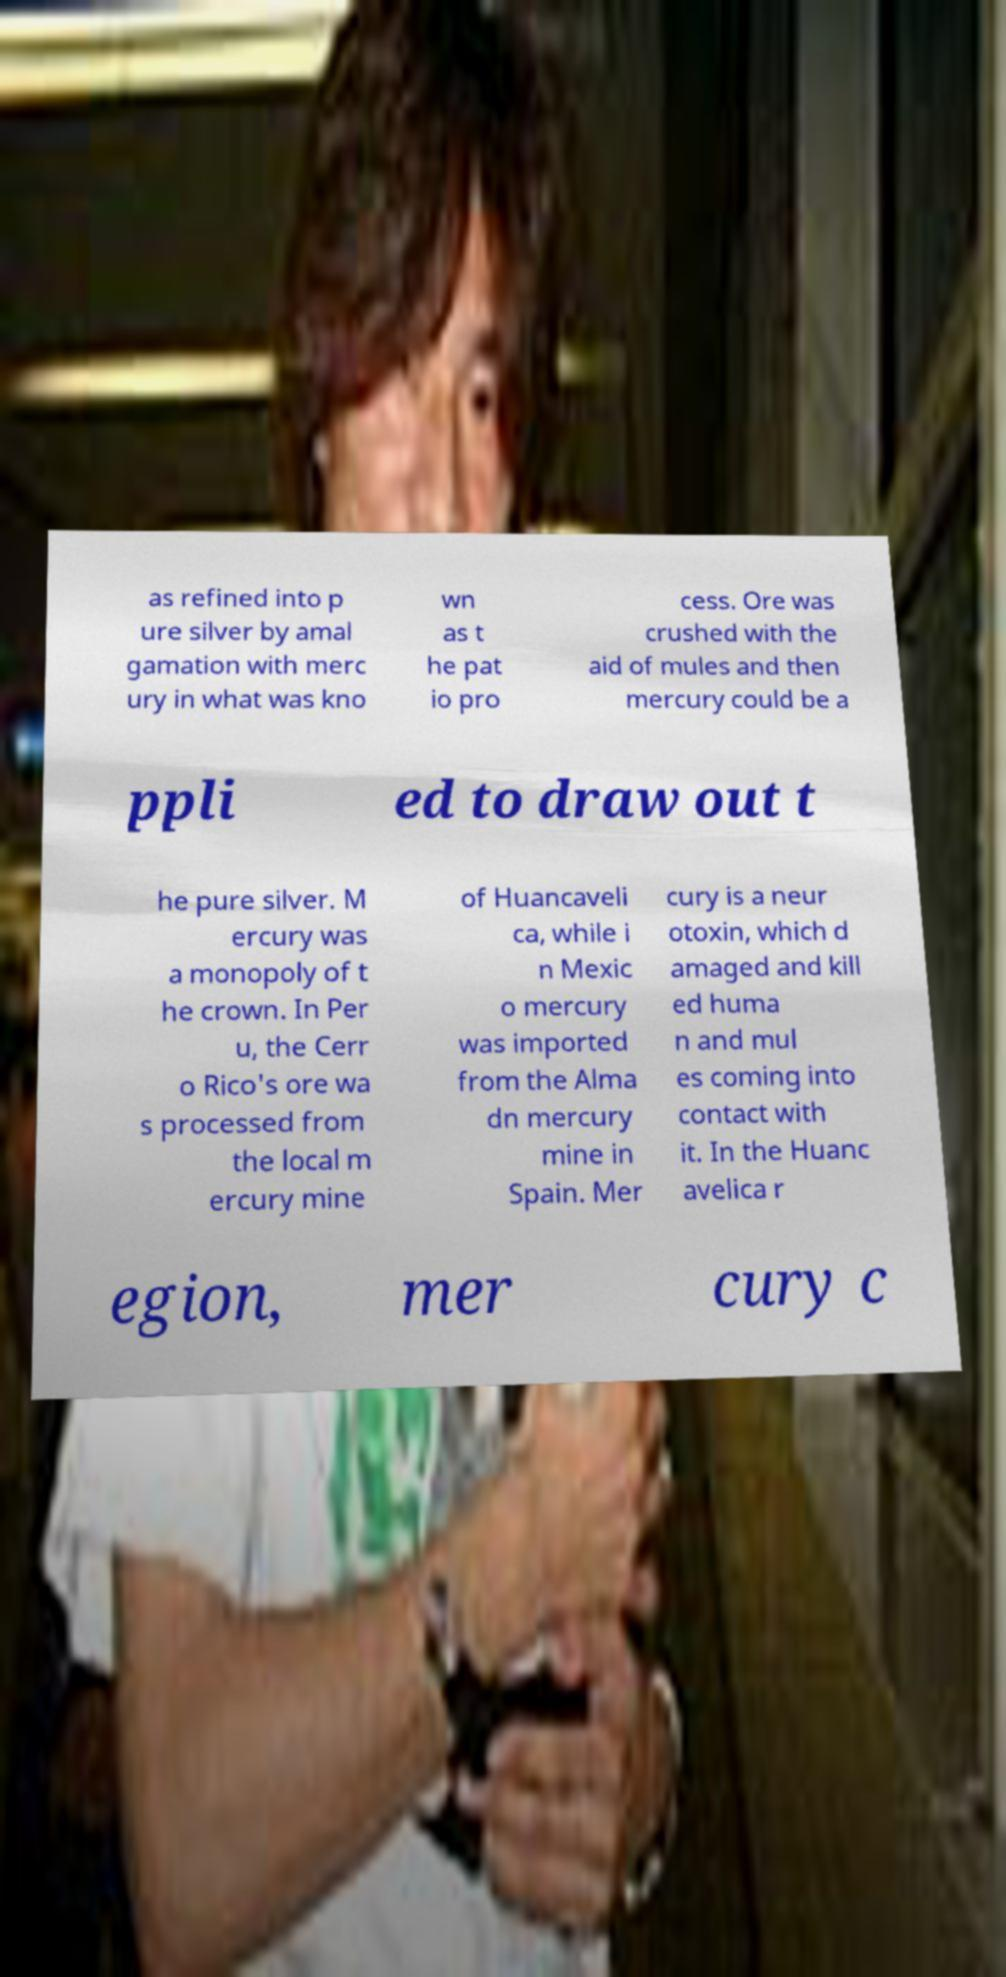What messages or text are displayed in this image? I need them in a readable, typed format. as refined into p ure silver by amal gamation with merc ury in what was kno wn as t he pat io pro cess. Ore was crushed with the aid of mules and then mercury could be a ppli ed to draw out t he pure silver. M ercury was a monopoly of t he crown. In Per u, the Cerr o Rico's ore wa s processed from the local m ercury mine of Huancaveli ca, while i n Mexic o mercury was imported from the Alma dn mercury mine in Spain. Mer cury is a neur otoxin, which d amaged and kill ed huma n and mul es coming into contact with it. In the Huanc avelica r egion, mer cury c 